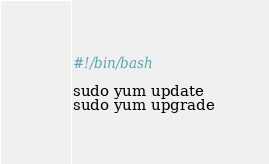<code> <loc_0><loc_0><loc_500><loc_500><_Bash_>#!/bin/bash

sudo yum update
sudo yum upgrade
</code> 